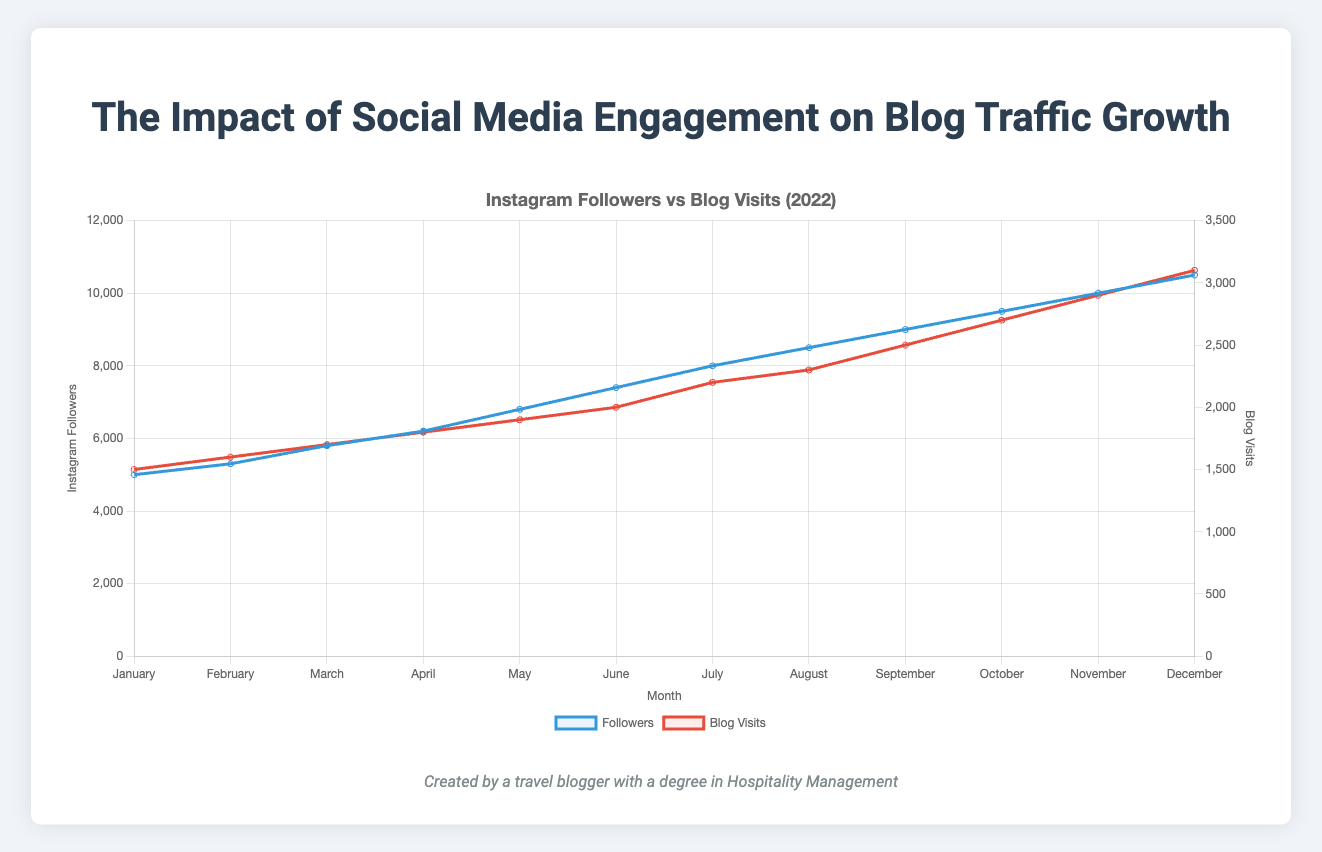What month had the highest number of blog visits? The month with the highest number of blog visits can be seen directly from the figure by observing the line representing blog visits. It peaks in December at 3,100 blog visits.
Answer: December How many more followers were there in December compared to July? To find the difference in followers between December and July, subtract the number of followers in July (8,000) from the number of followers in December (10,500). Difference = 10,500 - 8,000 = 2,500.
Answer: 2,500 Which had more rapid growth over the year, followers or blog visits? To determine which had more rapid growth, observe the slopes of the respective lines. The followers' increase from 5,000 to 10,500 indicates a gain of 5,500 followers, while blog visits increase from 1,500 to 3,100, indicating a gain of 1,600 visits. Growth rate comparison: Followers grew by 110% and Blog Visits grew by approximately 106.67%. Followers had a slightly more rapid growth.
Answer: Followers What is the increase in average likes per post from January to December? The average likes per post in January are 200, and in December it is 450. To find the increase, subtract the January value from the December value: 450 - 200 = 250.
Answer: 250 Compare the blog visits and followers in June. Which metric is higher and by how much? In June, there are 2,000 blog visits and 7,400 followers. The difference can be calculated by subtracting the blog visits from the followers: 7,400 - 2,000 = 5,400. Followers are higher by 5,400.
Answer: Followers by 5,400 Between which two consecutive months did followers see the largest increase? To find the largest increase between consecutive months, observe the jumps on the followers' line. The largest jump is seen from November (10,000) to December (10,500). The increase is 10,500 - 10,000 = 500.
Answer: November to December What is the growth rate of blog visits between January and June? Calculate the growth rate by dividing the difference in blog visits by the initial value and then multiplying by 100. The blog visits in June are 2,000, and in January they are 1,500. Growth rate = ((2,000 - 1,500) / 1,500) * 100 = 33.33%.
Answer: 33.33% What is the ratio of followers to blog visits in October? To find the ratio, divide the number of followers by the number of blog visits in October. Followers = 9,500; Blog visits = 2,700. Ratio = 9,500 / 2,700 ≈ 3.52.
Answer: 3.52 Which month showed the smallest increase in followers from the previous month? By comparing the increases month-over-month, the smallest increase in followers is from January (5,000) to February (5,300), where the increase is 300.
Answer: February How many posts were made in total from January to December? To find the total number of posts, sum the posts for each month: 15 + 18 + 20 + 22 + 25 + 28 + 30 + 32 + 35 + 38 + 40 + 42 = 345.
Answer: 345 